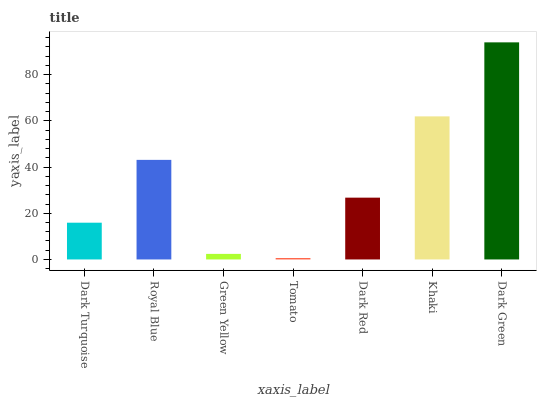Is Tomato the minimum?
Answer yes or no. Yes. Is Dark Green the maximum?
Answer yes or no. Yes. Is Royal Blue the minimum?
Answer yes or no. No. Is Royal Blue the maximum?
Answer yes or no. No. Is Royal Blue greater than Dark Turquoise?
Answer yes or no. Yes. Is Dark Turquoise less than Royal Blue?
Answer yes or no. Yes. Is Dark Turquoise greater than Royal Blue?
Answer yes or no. No. Is Royal Blue less than Dark Turquoise?
Answer yes or no. No. Is Dark Red the high median?
Answer yes or no. Yes. Is Dark Red the low median?
Answer yes or no. Yes. Is Dark Turquoise the high median?
Answer yes or no. No. Is Dark Turquoise the low median?
Answer yes or no. No. 